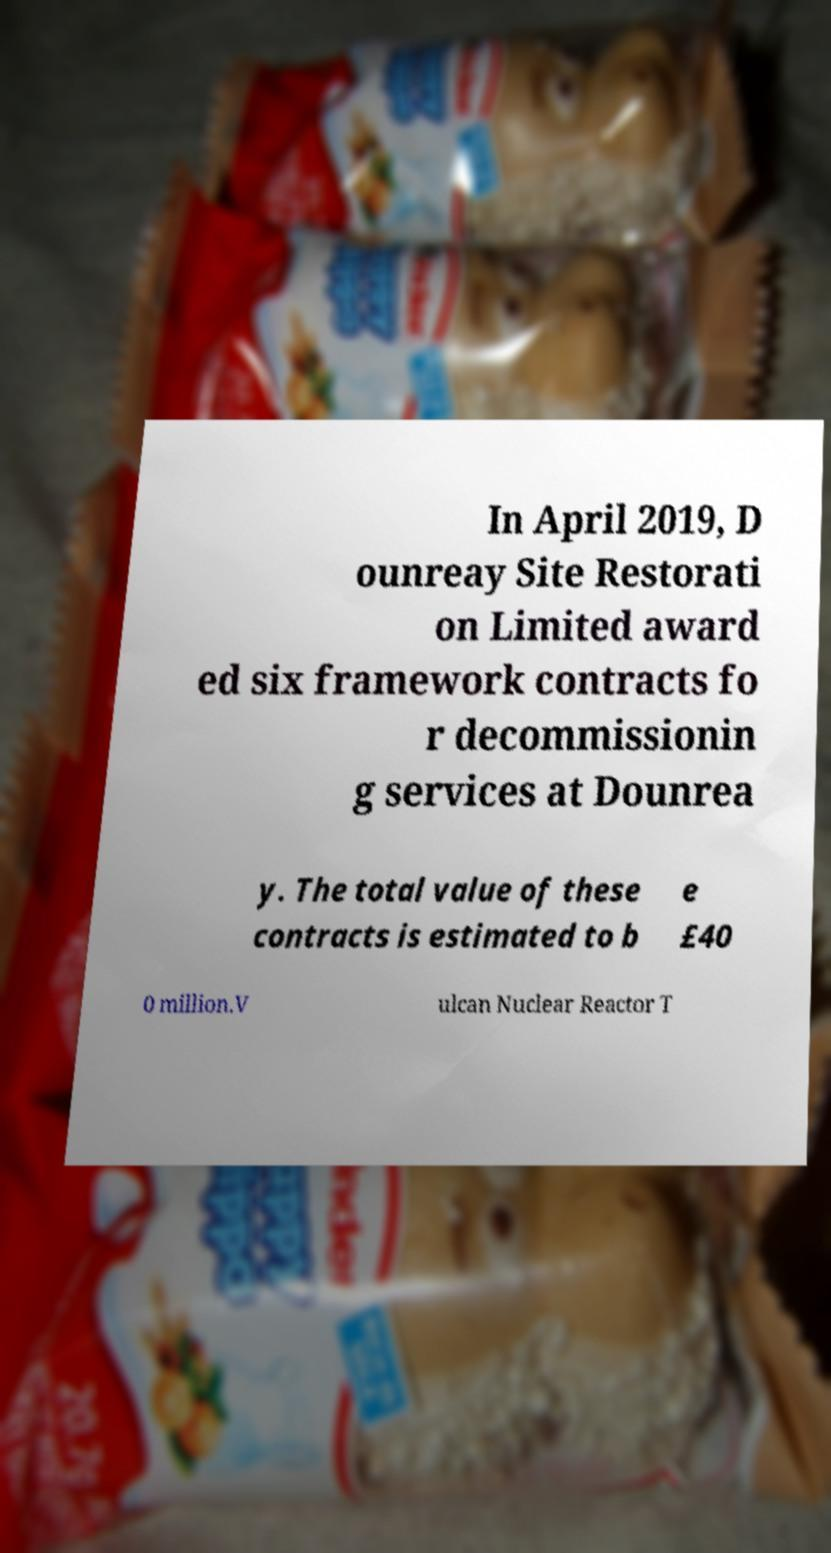Can you accurately transcribe the text from the provided image for me? In April 2019, D ounreay Site Restorati on Limited award ed six framework contracts fo r decommissionin g services at Dounrea y. The total value of these contracts is estimated to b e £40 0 million.V ulcan Nuclear Reactor T 